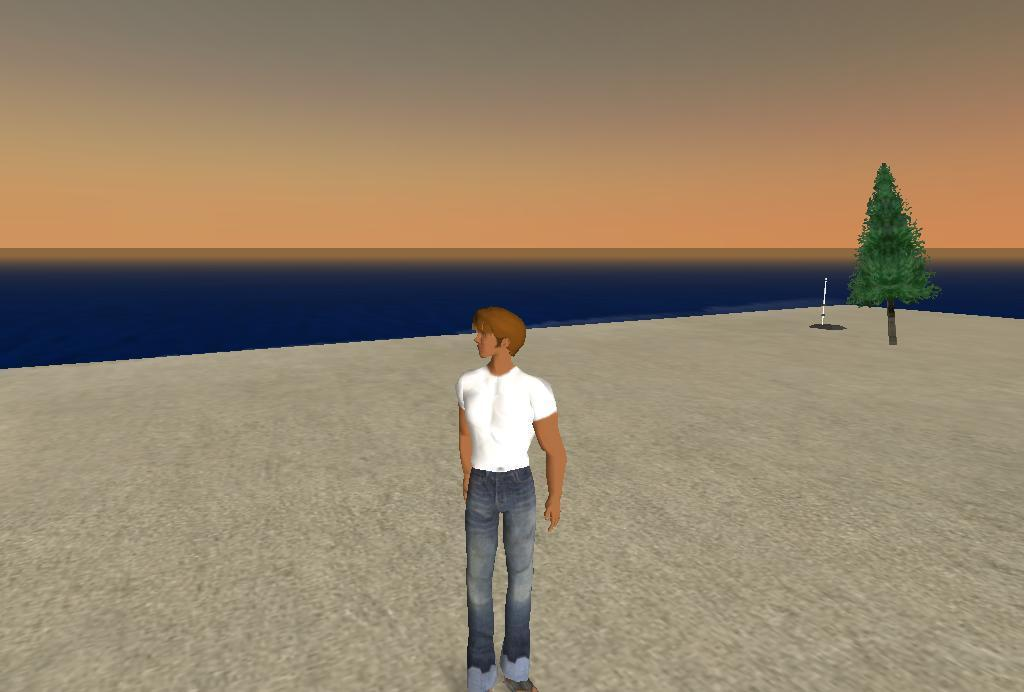What is the main subject of the image? There is a person standing in the image. What is the person standing on? The person is standing on a floor. What can be seen in the background of the image? There is a tree, a sea, and the sky visible in the background of the image. What type of power is being generated by the airplane in the image? There is no airplane present in the image, so no power is being generated. What sound can be heard coming from the sea in the image? The image is static, so no sound can be heard from the sea or any other element in the image. 